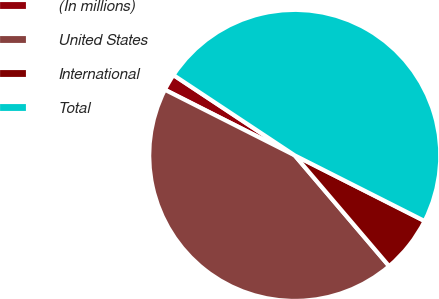Convert chart to OTSL. <chart><loc_0><loc_0><loc_500><loc_500><pie_chart><fcel>(In millions)<fcel>United States<fcel>International<fcel>Total<nl><fcel>1.86%<fcel>43.68%<fcel>6.32%<fcel>48.14%<nl></chart> 